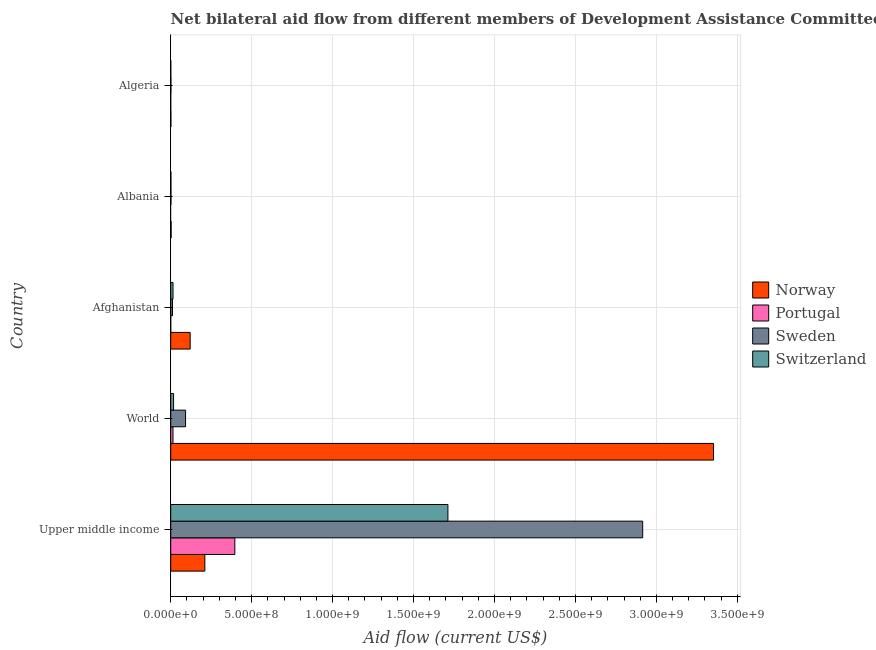How many different coloured bars are there?
Your response must be concise. 4. Are the number of bars per tick equal to the number of legend labels?
Your response must be concise. No. What is the label of the 5th group of bars from the top?
Keep it short and to the point. Upper middle income. What is the amount of aid given by portugal in Upper middle income?
Offer a very short reply. 3.96e+08. Across all countries, what is the maximum amount of aid given by portugal?
Your answer should be very brief. 3.96e+08. Across all countries, what is the minimum amount of aid given by sweden?
Make the answer very short. 1.18e+06. What is the total amount of aid given by portugal in the graph?
Provide a short and direct response. 4.10e+08. What is the difference between the amount of aid given by portugal in Upper middle income and that in World?
Your answer should be compact. 3.82e+08. What is the difference between the amount of aid given by switzerland in World and the amount of aid given by sweden in Afghanistan?
Your answer should be compact. 6.76e+06. What is the average amount of aid given by sweden per country?
Your answer should be very brief. 6.04e+08. What is the difference between the amount of aid given by sweden and amount of aid given by portugal in Algeria?
Make the answer very short. 1.14e+06. What is the ratio of the amount of aid given by sweden in Afghanistan to that in Albania?
Offer a terse response. 6.86. Is the amount of aid given by sweden in Upper middle income less than that in World?
Offer a very short reply. No. What is the difference between the highest and the second highest amount of aid given by sweden?
Give a very brief answer. 2.82e+09. What is the difference between the highest and the lowest amount of aid given by switzerland?
Ensure brevity in your answer.  1.71e+09. Is it the case that in every country, the sum of the amount of aid given by switzerland and amount of aid given by portugal is greater than the sum of amount of aid given by norway and amount of aid given by sweden?
Your response must be concise. No. Is it the case that in every country, the sum of the amount of aid given by norway and amount of aid given by portugal is greater than the amount of aid given by sweden?
Provide a short and direct response. No. Are all the bars in the graph horizontal?
Provide a short and direct response. Yes. What is the difference between two consecutive major ticks on the X-axis?
Make the answer very short. 5.00e+08. Are the values on the major ticks of X-axis written in scientific E-notation?
Offer a terse response. Yes. Does the graph contain any zero values?
Ensure brevity in your answer.  Yes. How many legend labels are there?
Offer a terse response. 4. How are the legend labels stacked?
Offer a terse response. Vertical. What is the title of the graph?
Your answer should be compact. Net bilateral aid flow from different members of Development Assistance Committee in the year 2010. What is the label or title of the X-axis?
Your response must be concise. Aid flow (current US$). What is the label or title of the Y-axis?
Give a very brief answer. Country. What is the Aid flow (current US$) of Norway in Upper middle income?
Offer a very short reply. 2.11e+08. What is the Aid flow (current US$) of Portugal in Upper middle income?
Provide a short and direct response. 3.96e+08. What is the Aid flow (current US$) in Sweden in Upper middle income?
Offer a very short reply. 2.92e+09. What is the Aid flow (current US$) in Switzerland in Upper middle income?
Provide a short and direct response. 1.71e+09. What is the Aid flow (current US$) in Norway in World?
Provide a succinct answer. 3.35e+09. What is the Aid flow (current US$) in Portugal in World?
Provide a short and direct response. 1.40e+07. What is the Aid flow (current US$) in Sweden in World?
Keep it short and to the point. 9.17e+07. What is the Aid flow (current US$) of Switzerland in World?
Offer a terse response. 1.77e+07. What is the Aid flow (current US$) of Norway in Afghanistan?
Make the answer very short. 1.20e+08. What is the Aid flow (current US$) of Sweden in Afghanistan?
Offer a terse response. 1.09e+07. What is the Aid flow (current US$) in Switzerland in Afghanistan?
Provide a succinct answer. 1.42e+07. What is the Aid flow (current US$) in Norway in Albania?
Provide a succinct answer. 2.51e+06. What is the Aid flow (current US$) in Sweden in Albania?
Provide a succinct answer. 1.59e+06. What is the Aid flow (current US$) of Switzerland in Albania?
Provide a short and direct response. 1.14e+06. What is the Aid flow (current US$) in Norway in Algeria?
Make the answer very short. 1.02e+06. What is the Aid flow (current US$) in Sweden in Algeria?
Provide a short and direct response. 1.18e+06. Across all countries, what is the maximum Aid flow (current US$) in Norway?
Ensure brevity in your answer.  3.35e+09. Across all countries, what is the maximum Aid flow (current US$) of Portugal?
Make the answer very short. 3.96e+08. Across all countries, what is the maximum Aid flow (current US$) in Sweden?
Offer a terse response. 2.92e+09. Across all countries, what is the maximum Aid flow (current US$) of Switzerland?
Make the answer very short. 1.71e+09. Across all countries, what is the minimum Aid flow (current US$) in Norway?
Keep it short and to the point. 1.02e+06. Across all countries, what is the minimum Aid flow (current US$) of Portugal?
Offer a very short reply. 0. Across all countries, what is the minimum Aid flow (current US$) of Sweden?
Your answer should be compact. 1.18e+06. Across all countries, what is the minimum Aid flow (current US$) of Switzerland?
Your answer should be very brief. 4.00e+05. What is the total Aid flow (current US$) in Norway in the graph?
Your answer should be compact. 3.69e+09. What is the total Aid flow (current US$) in Portugal in the graph?
Your answer should be compact. 4.10e+08. What is the total Aid flow (current US$) of Sweden in the graph?
Keep it short and to the point. 3.02e+09. What is the total Aid flow (current US$) in Switzerland in the graph?
Offer a terse response. 1.75e+09. What is the difference between the Aid flow (current US$) in Norway in Upper middle income and that in World?
Provide a short and direct response. -3.14e+09. What is the difference between the Aid flow (current US$) in Portugal in Upper middle income and that in World?
Give a very brief answer. 3.82e+08. What is the difference between the Aid flow (current US$) of Sweden in Upper middle income and that in World?
Provide a succinct answer. 2.82e+09. What is the difference between the Aid flow (current US$) in Switzerland in Upper middle income and that in World?
Give a very brief answer. 1.69e+09. What is the difference between the Aid flow (current US$) in Norway in Upper middle income and that in Afghanistan?
Ensure brevity in your answer.  9.06e+07. What is the difference between the Aid flow (current US$) of Portugal in Upper middle income and that in Afghanistan?
Your answer should be very brief. 3.96e+08. What is the difference between the Aid flow (current US$) of Sweden in Upper middle income and that in Afghanistan?
Make the answer very short. 2.90e+09. What is the difference between the Aid flow (current US$) of Switzerland in Upper middle income and that in Afghanistan?
Provide a short and direct response. 1.70e+09. What is the difference between the Aid flow (current US$) of Norway in Upper middle income and that in Albania?
Your answer should be very brief. 2.08e+08. What is the difference between the Aid flow (current US$) of Sweden in Upper middle income and that in Albania?
Give a very brief answer. 2.91e+09. What is the difference between the Aid flow (current US$) of Switzerland in Upper middle income and that in Albania?
Provide a short and direct response. 1.71e+09. What is the difference between the Aid flow (current US$) of Norway in Upper middle income and that in Algeria?
Give a very brief answer. 2.10e+08. What is the difference between the Aid flow (current US$) of Portugal in Upper middle income and that in Algeria?
Give a very brief answer. 3.96e+08. What is the difference between the Aid flow (current US$) in Sweden in Upper middle income and that in Algeria?
Offer a terse response. 2.91e+09. What is the difference between the Aid flow (current US$) of Switzerland in Upper middle income and that in Algeria?
Give a very brief answer. 1.71e+09. What is the difference between the Aid flow (current US$) in Norway in World and that in Afghanistan?
Make the answer very short. 3.23e+09. What is the difference between the Aid flow (current US$) in Portugal in World and that in Afghanistan?
Your answer should be compact. 1.40e+07. What is the difference between the Aid flow (current US$) of Sweden in World and that in Afghanistan?
Keep it short and to the point. 8.08e+07. What is the difference between the Aid flow (current US$) of Switzerland in World and that in Afghanistan?
Provide a short and direct response. 3.46e+06. What is the difference between the Aid flow (current US$) in Norway in World and that in Albania?
Provide a succinct answer. 3.35e+09. What is the difference between the Aid flow (current US$) of Sweden in World and that in Albania?
Provide a short and direct response. 9.01e+07. What is the difference between the Aid flow (current US$) of Switzerland in World and that in Albania?
Provide a short and direct response. 1.65e+07. What is the difference between the Aid flow (current US$) in Norway in World and that in Algeria?
Ensure brevity in your answer.  3.35e+09. What is the difference between the Aid flow (current US$) in Portugal in World and that in Algeria?
Provide a short and direct response. 1.40e+07. What is the difference between the Aid flow (current US$) in Sweden in World and that in Algeria?
Offer a terse response. 9.05e+07. What is the difference between the Aid flow (current US$) in Switzerland in World and that in Algeria?
Give a very brief answer. 1.73e+07. What is the difference between the Aid flow (current US$) in Norway in Afghanistan and that in Albania?
Give a very brief answer. 1.18e+08. What is the difference between the Aid flow (current US$) in Sweden in Afghanistan and that in Albania?
Offer a terse response. 9.31e+06. What is the difference between the Aid flow (current US$) in Switzerland in Afghanistan and that in Albania?
Provide a succinct answer. 1.31e+07. What is the difference between the Aid flow (current US$) in Norway in Afghanistan and that in Algeria?
Your response must be concise. 1.19e+08. What is the difference between the Aid flow (current US$) of Portugal in Afghanistan and that in Algeria?
Make the answer very short. -2.00e+04. What is the difference between the Aid flow (current US$) of Sweden in Afghanistan and that in Algeria?
Give a very brief answer. 9.72e+06. What is the difference between the Aid flow (current US$) of Switzerland in Afghanistan and that in Algeria?
Provide a succinct answer. 1.38e+07. What is the difference between the Aid flow (current US$) of Norway in Albania and that in Algeria?
Your response must be concise. 1.49e+06. What is the difference between the Aid flow (current US$) of Sweden in Albania and that in Algeria?
Keep it short and to the point. 4.10e+05. What is the difference between the Aid flow (current US$) in Switzerland in Albania and that in Algeria?
Give a very brief answer. 7.40e+05. What is the difference between the Aid flow (current US$) of Norway in Upper middle income and the Aid flow (current US$) of Portugal in World?
Provide a succinct answer. 1.97e+08. What is the difference between the Aid flow (current US$) in Norway in Upper middle income and the Aid flow (current US$) in Sweden in World?
Keep it short and to the point. 1.19e+08. What is the difference between the Aid flow (current US$) of Norway in Upper middle income and the Aid flow (current US$) of Switzerland in World?
Give a very brief answer. 1.93e+08. What is the difference between the Aid flow (current US$) of Portugal in Upper middle income and the Aid flow (current US$) of Sweden in World?
Make the answer very short. 3.04e+08. What is the difference between the Aid flow (current US$) of Portugal in Upper middle income and the Aid flow (current US$) of Switzerland in World?
Offer a very short reply. 3.78e+08. What is the difference between the Aid flow (current US$) of Sweden in Upper middle income and the Aid flow (current US$) of Switzerland in World?
Keep it short and to the point. 2.90e+09. What is the difference between the Aid flow (current US$) in Norway in Upper middle income and the Aid flow (current US$) in Portugal in Afghanistan?
Your answer should be compact. 2.11e+08. What is the difference between the Aid flow (current US$) of Norway in Upper middle income and the Aid flow (current US$) of Sweden in Afghanistan?
Offer a terse response. 2.00e+08. What is the difference between the Aid flow (current US$) in Norway in Upper middle income and the Aid flow (current US$) in Switzerland in Afghanistan?
Ensure brevity in your answer.  1.97e+08. What is the difference between the Aid flow (current US$) of Portugal in Upper middle income and the Aid flow (current US$) of Sweden in Afghanistan?
Your response must be concise. 3.85e+08. What is the difference between the Aid flow (current US$) of Portugal in Upper middle income and the Aid flow (current US$) of Switzerland in Afghanistan?
Ensure brevity in your answer.  3.82e+08. What is the difference between the Aid flow (current US$) in Sweden in Upper middle income and the Aid flow (current US$) in Switzerland in Afghanistan?
Give a very brief answer. 2.90e+09. What is the difference between the Aid flow (current US$) of Norway in Upper middle income and the Aid flow (current US$) of Sweden in Albania?
Ensure brevity in your answer.  2.09e+08. What is the difference between the Aid flow (current US$) of Norway in Upper middle income and the Aid flow (current US$) of Switzerland in Albania?
Provide a succinct answer. 2.10e+08. What is the difference between the Aid flow (current US$) in Portugal in Upper middle income and the Aid flow (current US$) in Sweden in Albania?
Give a very brief answer. 3.94e+08. What is the difference between the Aid flow (current US$) in Portugal in Upper middle income and the Aid flow (current US$) in Switzerland in Albania?
Your answer should be very brief. 3.95e+08. What is the difference between the Aid flow (current US$) of Sweden in Upper middle income and the Aid flow (current US$) of Switzerland in Albania?
Keep it short and to the point. 2.91e+09. What is the difference between the Aid flow (current US$) in Norway in Upper middle income and the Aid flow (current US$) in Portugal in Algeria?
Give a very brief answer. 2.11e+08. What is the difference between the Aid flow (current US$) of Norway in Upper middle income and the Aid flow (current US$) of Sweden in Algeria?
Keep it short and to the point. 2.10e+08. What is the difference between the Aid flow (current US$) of Norway in Upper middle income and the Aid flow (current US$) of Switzerland in Algeria?
Provide a succinct answer. 2.10e+08. What is the difference between the Aid flow (current US$) of Portugal in Upper middle income and the Aid flow (current US$) of Sweden in Algeria?
Provide a short and direct response. 3.95e+08. What is the difference between the Aid flow (current US$) in Portugal in Upper middle income and the Aid flow (current US$) in Switzerland in Algeria?
Your response must be concise. 3.96e+08. What is the difference between the Aid flow (current US$) of Sweden in Upper middle income and the Aid flow (current US$) of Switzerland in Algeria?
Offer a very short reply. 2.91e+09. What is the difference between the Aid flow (current US$) in Norway in World and the Aid flow (current US$) in Portugal in Afghanistan?
Provide a short and direct response. 3.35e+09. What is the difference between the Aid flow (current US$) of Norway in World and the Aid flow (current US$) of Sweden in Afghanistan?
Keep it short and to the point. 3.34e+09. What is the difference between the Aid flow (current US$) of Norway in World and the Aid flow (current US$) of Switzerland in Afghanistan?
Provide a short and direct response. 3.34e+09. What is the difference between the Aid flow (current US$) in Portugal in World and the Aid flow (current US$) in Sweden in Afghanistan?
Offer a terse response. 3.11e+06. What is the difference between the Aid flow (current US$) of Portugal in World and the Aid flow (current US$) of Switzerland in Afghanistan?
Give a very brief answer. -1.90e+05. What is the difference between the Aid flow (current US$) of Sweden in World and the Aid flow (current US$) of Switzerland in Afghanistan?
Your response must be concise. 7.75e+07. What is the difference between the Aid flow (current US$) in Norway in World and the Aid flow (current US$) in Sweden in Albania?
Make the answer very short. 3.35e+09. What is the difference between the Aid flow (current US$) in Norway in World and the Aid flow (current US$) in Switzerland in Albania?
Your answer should be compact. 3.35e+09. What is the difference between the Aid flow (current US$) of Portugal in World and the Aid flow (current US$) of Sweden in Albania?
Your answer should be compact. 1.24e+07. What is the difference between the Aid flow (current US$) of Portugal in World and the Aid flow (current US$) of Switzerland in Albania?
Your answer should be very brief. 1.29e+07. What is the difference between the Aid flow (current US$) in Sweden in World and the Aid flow (current US$) in Switzerland in Albania?
Make the answer very short. 9.06e+07. What is the difference between the Aid flow (current US$) in Norway in World and the Aid flow (current US$) in Portugal in Algeria?
Offer a very short reply. 3.35e+09. What is the difference between the Aid flow (current US$) in Norway in World and the Aid flow (current US$) in Sweden in Algeria?
Offer a very short reply. 3.35e+09. What is the difference between the Aid flow (current US$) of Norway in World and the Aid flow (current US$) of Switzerland in Algeria?
Give a very brief answer. 3.35e+09. What is the difference between the Aid flow (current US$) in Portugal in World and the Aid flow (current US$) in Sweden in Algeria?
Your answer should be very brief. 1.28e+07. What is the difference between the Aid flow (current US$) in Portugal in World and the Aid flow (current US$) in Switzerland in Algeria?
Offer a very short reply. 1.36e+07. What is the difference between the Aid flow (current US$) in Sweden in World and the Aid flow (current US$) in Switzerland in Algeria?
Ensure brevity in your answer.  9.13e+07. What is the difference between the Aid flow (current US$) of Norway in Afghanistan and the Aid flow (current US$) of Sweden in Albania?
Offer a terse response. 1.19e+08. What is the difference between the Aid flow (current US$) in Norway in Afghanistan and the Aid flow (current US$) in Switzerland in Albania?
Provide a short and direct response. 1.19e+08. What is the difference between the Aid flow (current US$) of Portugal in Afghanistan and the Aid flow (current US$) of Sweden in Albania?
Your answer should be very brief. -1.57e+06. What is the difference between the Aid flow (current US$) in Portugal in Afghanistan and the Aid flow (current US$) in Switzerland in Albania?
Provide a short and direct response. -1.12e+06. What is the difference between the Aid flow (current US$) of Sweden in Afghanistan and the Aid flow (current US$) of Switzerland in Albania?
Your answer should be compact. 9.76e+06. What is the difference between the Aid flow (current US$) of Norway in Afghanistan and the Aid flow (current US$) of Portugal in Algeria?
Ensure brevity in your answer.  1.20e+08. What is the difference between the Aid flow (current US$) of Norway in Afghanistan and the Aid flow (current US$) of Sweden in Algeria?
Make the answer very short. 1.19e+08. What is the difference between the Aid flow (current US$) of Norway in Afghanistan and the Aid flow (current US$) of Switzerland in Algeria?
Make the answer very short. 1.20e+08. What is the difference between the Aid flow (current US$) in Portugal in Afghanistan and the Aid flow (current US$) in Sweden in Algeria?
Offer a terse response. -1.16e+06. What is the difference between the Aid flow (current US$) in Portugal in Afghanistan and the Aid flow (current US$) in Switzerland in Algeria?
Make the answer very short. -3.80e+05. What is the difference between the Aid flow (current US$) of Sweden in Afghanistan and the Aid flow (current US$) of Switzerland in Algeria?
Offer a very short reply. 1.05e+07. What is the difference between the Aid flow (current US$) in Norway in Albania and the Aid flow (current US$) in Portugal in Algeria?
Provide a succinct answer. 2.47e+06. What is the difference between the Aid flow (current US$) of Norway in Albania and the Aid flow (current US$) of Sweden in Algeria?
Give a very brief answer. 1.33e+06. What is the difference between the Aid flow (current US$) in Norway in Albania and the Aid flow (current US$) in Switzerland in Algeria?
Your answer should be compact. 2.11e+06. What is the difference between the Aid flow (current US$) in Sweden in Albania and the Aid flow (current US$) in Switzerland in Algeria?
Your answer should be very brief. 1.19e+06. What is the average Aid flow (current US$) of Norway per country?
Your answer should be compact. 7.37e+08. What is the average Aid flow (current US$) in Portugal per country?
Your answer should be very brief. 8.20e+07. What is the average Aid flow (current US$) in Sweden per country?
Your answer should be very brief. 6.04e+08. What is the average Aid flow (current US$) of Switzerland per country?
Your answer should be compact. 3.49e+08. What is the difference between the Aid flow (current US$) of Norway and Aid flow (current US$) of Portugal in Upper middle income?
Offer a terse response. -1.85e+08. What is the difference between the Aid flow (current US$) in Norway and Aid flow (current US$) in Sweden in Upper middle income?
Your response must be concise. -2.70e+09. What is the difference between the Aid flow (current US$) of Norway and Aid flow (current US$) of Switzerland in Upper middle income?
Offer a very short reply. -1.50e+09. What is the difference between the Aid flow (current US$) in Portugal and Aid flow (current US$) in Sweden in Upper middle income?
Ensure brevity in your answer.  -2.52e+09. What is the difference between the Aid flow (current US$) of Portugal and Aid flow (current US$) of Switzerland in Upper middle income?
Your answer should be very brief. -1.32e+09. What is the difference between the Aid flow (current US$) of Sweden and Aid flow (current US$) of Switzerland in Upper middle income?
Your answer should be compact. 1.20e+09. What is the difference between the Aid flow (current US$) in Norway and Aid flow (current US$) in Portugal in World?
Provide a short and direct response. 3.34e+09. What is the difference between the Aid flow (current US$) of Norway and Aid flow (current US$) of Sweden in World?
Your answer should be very brief. 3.26e+09. What is the difference between the Aid flow (current US$) in Norway and Aid flow (current US$) in Switzerland in World?
Provide a short and direct response. 3.34e+09. What is the difference between the Aid flow (current US$) in Portugal and Aid flow (current US$) in Sweden in World?
Provide a succinct answer. -7.77e+07. What is the difference between the Aid flow (current US$) of Portugal and Aid flow (current US$) of Switzerland in World?
Your response must be concise. -3.65e+06. What is the difference between the Aid flow (current US$) in Sweden and Aid flow (current US$) in Switzerland in World?
Make the answer very short. 7.41e+07. What is the difference between the Aid flow (current US$) of Norway and Aid flow (current US$) of Portugal in Afghanistan?
Your answer should be compact. 1.20e+08. What is the difference between the Aid flow (current US$) in Norway and Aid flow (current US$) in Sweden in Afghanistan?
Ensure brevity in your answer.  1.09e+08. What is the difference between the Aid flow (current US$) of Norway and Aid flow (current US$) of Switzerland in Afghanistan?
Keep it short and to the point. 1.06e+08. What is the difference between the Aid flow (current US$) in Portugal and Aid flow (current US$) in Sweden in Afghanistan?
Provide a short and direct response. -1.09e+07. What is the difference between the Aid flow (current US$) in Portugal and Aid flow (current US$) in Switzerland in Afghanistan?
Make the answer very short. -1.42e+07. What is the difference between the Aid flow (current US$) in Sweden and Aid flow (current US$) in Switzerland in Afghanistan?
Ensure brevity in your answer.  -3.30e+06. What is the difference between the Aid flow (current US$) in Norway and Aid flow (current US$) in Sweden in Albania?
Your answer should be very brief. 9.20e+05. What is the difference between the Aid flow (current US$) in Norway and Aid flow (current US$) in Switzerland in Albania?
Offer a very short reply. 1.37e+06. What is the difference between the Aid flow (current US$) of Sweden and Aid flow (current US$) of Switzerland in Albania?
Keep it short and to the point. 4.50e+05. What is the difference between the Aid flow (current US$) of Norway and Aid flow (current US$) of Portugal in Algeria?
Offer a terse response. 9.80e+05. What is the difference between the Aid flow (current US$) of Norway and Aid flow (current US$) of Sweden in Algeria?
Keep it short and to the point. -1.60e+05. What is the difference between the Aid flow (current US$) of Norway and Aid flow (current US$) of Switzerland in Algeria?
Offer a very short reply. 6.20e+05. What is the difference between the Aid flow (current US$) in Portugal and Aid flow (current US$) in Sweden in Algeria?
Provide a short and direct response. -1.14e+06. What is the difference between the Aid flow (current US$) of Portugal and Aid flow (current US$) of Switzerland in Algeria?
Offer a terse response. -3.60e+05. What is the difference between the Aid flow (current US$) in Sweden and Aid flow (current US$) in Switzerland in Algeria?
Your answer should be very brief. 7.80e+05. What is the ratio of the Aid flow (current US$) of Norway in Upper middle income to that in World?
Ensure brevity in your answer.  0.06. What is the ratio of the Aid flow (current US$) of Portugal in Upper middle income to that in World?
Your answer should be very brief. 28.27. What is the ratio of the Aid flow (current US$) in Sweden in Upper middle income to that in World?
Make the answer very short. 31.78. What is the ratio of the Aid flow (current US$) of Switzerland in Upper middle income to that in World?
Ensure brevity in your answer.  96.96. What is the ratio of the Aid flow (current US$) in Norway in Upper middle income to that in Afghanistan?
Ensure brevity in your answer.  1.75. What is the ratio of the Aid flow (current US$) in Portugal in Upper middle income to that in Afghanistan?
Keep it short and to the point. 1.98e+04. What is the ratio of the Aid flow (current US$) in Sweden in Upper middle income to that in Afghanistan?
Offer a terse response. 267.45. What is the ratio of the Aid flow (current US$) of Switzerland in Upper middle income to that in Afghanistan?
Your answer should be very brief. 120.58. What is the ratio of the Aid flow (current US$) of Norway in Upper middle income to that in Albania?
Give a very brief answer. 83.99. What is the ratio of the Aid flow (current US$) of Sweden in Upper middle income to that in Albania?
Give a very brief answer. 1833.49. What is the ratio of the Aid flow (current US$) in Switzerland in Upper middle income to that in Albania?
Your response must be concise. 1502.01. What is the ratio of the Aid flow (current US$) in Norway in Upper middle income to that in Algeria?
Your answer should be very brief. 206.68. What is the ratio of the Aid flow (current US$) in Portugal in Upper middle income to that in Algeria?
Provide a short and direct response. 9901.75. What is the ratio of the Aid flow (current US$) of Sweden in Upper middle income to that in Algeria?
Your answer should be very brief. 2470.55. What is the ratio of the Aid flow (current US$) in Switzerland in Upper middle income to that in Algeria?
Provide a short and direct response. 4280.73. What is the ratio of the Aid flow (current US$) in Norway in World to that in Afghanistan?
Make the answer very short. 27.9. What is the ratio of the Aid flow (current US$) of Portugal in World to that in Afghanistan?
Make the answer very short. 700.5. What is the ratio of the Aid flow (current US$) in Sweden in World to that in Afghanistan?
Offer a terse response. 8.41. What is the ratio of the Aid flow (current US$) of Switzerland in World to that in Afghanistan?
Your response must be concise. 1.24. What is the ratio of the Aid flow (current US$) of Norway in World to that in Albania?
Ensure brevity in your answer.  1335.83. What is the ratio of the Aid flow (current US$) in Sweden in World to that in Albania?
Ensure brevity in your answer.  57.69. What is the ratio of the Aid flow (current US$) of Switzerland in World to that in Albania?
Provide a short and direct response. 15.49. What is the ratio of the Aid flow (current US$) of Norway in World to that in Algeria?
Ensure brevity in your answer.  3287.19. What is the ratio of the Aid flow (current US$) of Portugal in World to that in Algeria?
Make the answer very short. 350.25. What is the ratio of the Aid flow (current US$) in Sweden in World to that in Algeria?
Provide a succinct answer. 77.73. What is the ratio of the Aid flow (current US$) of Switzerland in World to that in Algeria?
Provide a succinct answer. 44.15. What is the ratio of the Aid flow (current US$) of Norway in Afghanistan to that in Albania?
Offer a very short reply. 47.88. What is the ratio of the Aid flow (current US$) of Sweden in Afghanistan to that in Albania?
Ensure brevity in your answer.  6.86. What is the ratio of the Aid flow (current US$) in Switzerland in Afghanistan to that in Albania?
Your answer should be very brief. 12.46. What is the ratio of the Aid flow (current US$) of Norway in Afghanistan to that in Algeria?
Keep it short and to the point. 117.82. What is the ratio of the Aid flow (current US$) in Sweden in Afghanistan to that in Algeria?
Offer a terse response. 9.24. What is the ratio of the Aid flow (current US$) of Switzerland in Afghanistan to that in Algeria?
Give a very brief answer. 35.5. What is the ratio of the Aid flow (current US$) in Norway in Albania to that in Algeria?
Your response must be concise. 2.46. What is the ratio of the Aid flow (current US$) in Sweden in Albania to that in Algeria?
Offer a very short reply. 1.35. What is the ratio of the Aid flow (current US$) of Switzerland in Albania to that in Algeria?
Keep it short and to the point. 2.85. What is the difference between the highest and the second highest Aid flow (current US$) in Norway?
Your response must be concise. 3.14e+09. What is the difference between the highest and the second highest Aid flow (current US$) in Portugal?
Offer a very short reply. 3.82e+08. What is the difference between the highest and the second highest Aid flow (current US$) of Sweden?
Offer a terse response. 2.82e+09. What is the difference between the highest and the second highest Aid flow (current US$) in Switzerland?
Provide a succinct answer. 1.69e+09. What is the difference between the highest and the lowest Aid flow (current US$) in Norway?
Provide a short and direct response. 3.35e+09. What is the difference between the highest and the lowest Aid flow (current US$) in Portugal?
Offer a very short reply. 3.96e+08. What is the difference between the highest and the lowest Aid flow (current US$) of Sweden?
Give a very brief answer. 2.91e+09. What is the difference between the highest and the lowest Aid flow (current US$) of Switzerland?
Your response must be concise. 1.71e+09. 